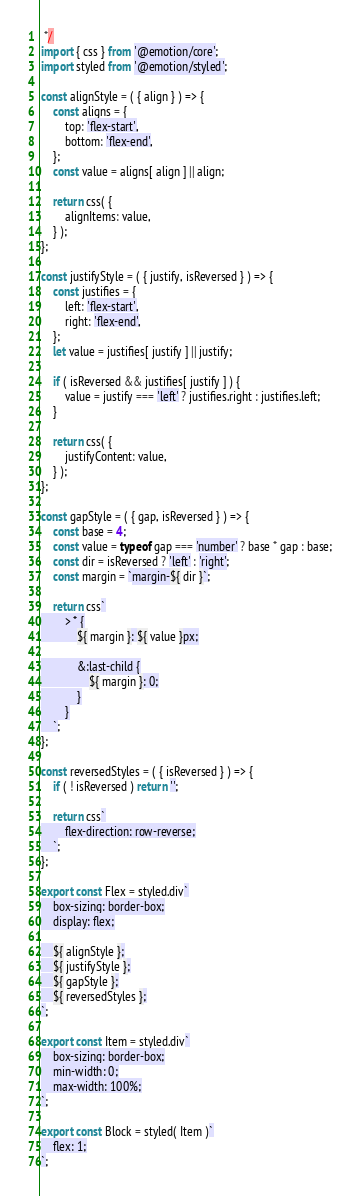Convert code to text. <code><loc_0><loc_0><loc_500><loc_500><_JavaScript_> */
import { css } from '@emotion/core';
import styled from '@emotion/styled';

const alignStyle = ( { align } ) => {
	const aligns = {
		top: 'flex-start',
		bottom: 'flex-end',
	};
	const value = aligns[ align ] || align;

	return css( {
		alignItems: value,
	} );
};

const justifyStyle = ( { justify, isReversed } ) => {
	const justifies = {
		left: 'flex-start',
		right: 'flex-end',
	};
	let value = justifies[ justify ] || justify;

	if ( isReversed && justifies[ justify ] ) {
		value = justify === 'left' ? justifies.right : justifies.left;
	}

	return css( {
		justifyContent: value,
	} );
};

const gapStyle = ( { gap, isReversed } ) => {
	const base = 4;
	const value = typeof gap === 'number' ? base * gap : base;
	const dir = isReversed ? 'left' : 'right';
	const margin = `margin-${ dir }`;

	return css`
		> * {
			${ margin }: ${ value }px;

			&:last-child {
				${ margin }: 0;
			}
		}
	`;
};

const reversedStyles = ( { isReversed } ) => {
	if ( ! isReversed ) return '';

	return css`
		flex-direction: row-reverse;
	`;
};

export const Flex = styled.div`
	box-sizing: border-box;
	display: flex;

	${ alignStyle };
	${ justifyStyle };
	${ gapStyle };
	${ reversedStyles };
`;

export const Item = styled.div`
	box-sizing: border-box;
	min-width: 0;
	max-width: 100%;
`;

export const Block = styled( Item )`
	flex: 1;
`;
</code> 